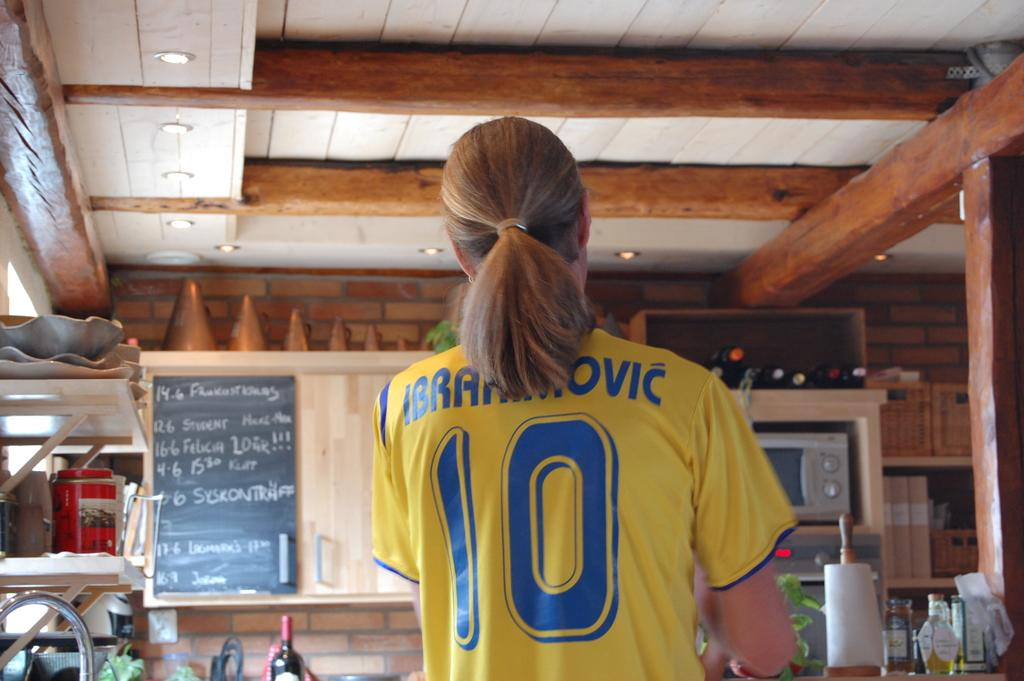<image>
Give a short and clear explanation of the subsequent image. Athlete standing with a yellow jersey on that has the number 10 in blue. 